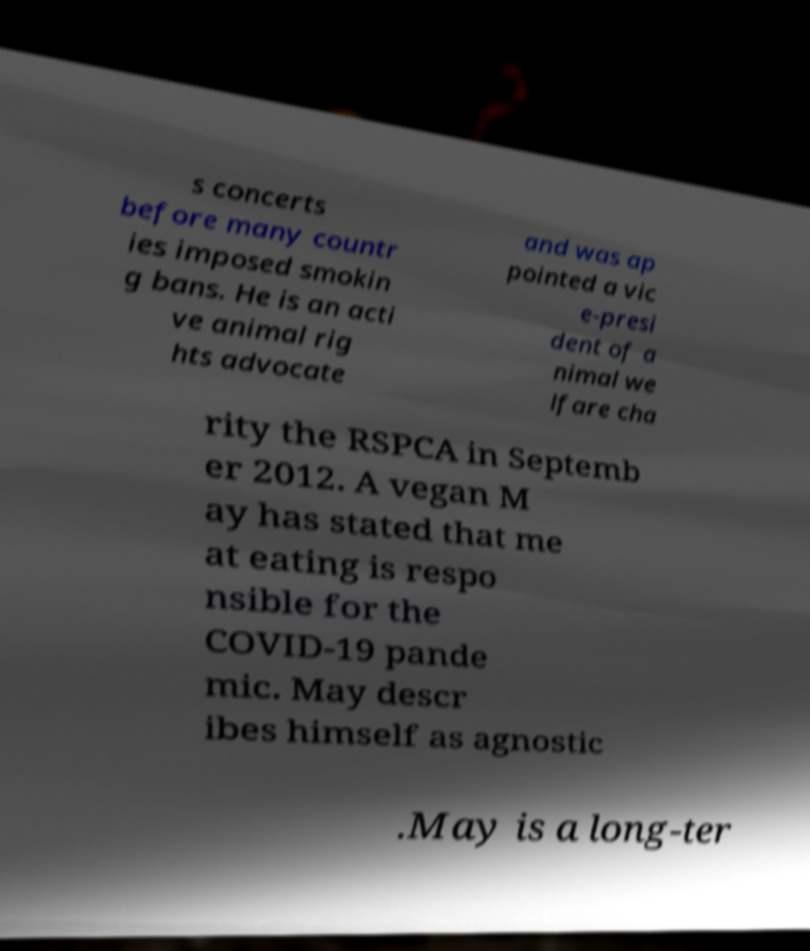Can you read and provide the text displayed in the image?This photo seems to have some interesting text. Can you extract and type it out for me? s concerts before many countr ies imposed smokin g bans. He is an acti ve animal rig hts advocate and was ap pointed a vic e-presi dent of a nimal we lfare cha rity the RSPCA in Septemb er 2012. A vegan M ay has stated that me at eating is respo nsible for the COVID-19 pande mic. May descr ibes himself as agnostic .May is a long-ter 